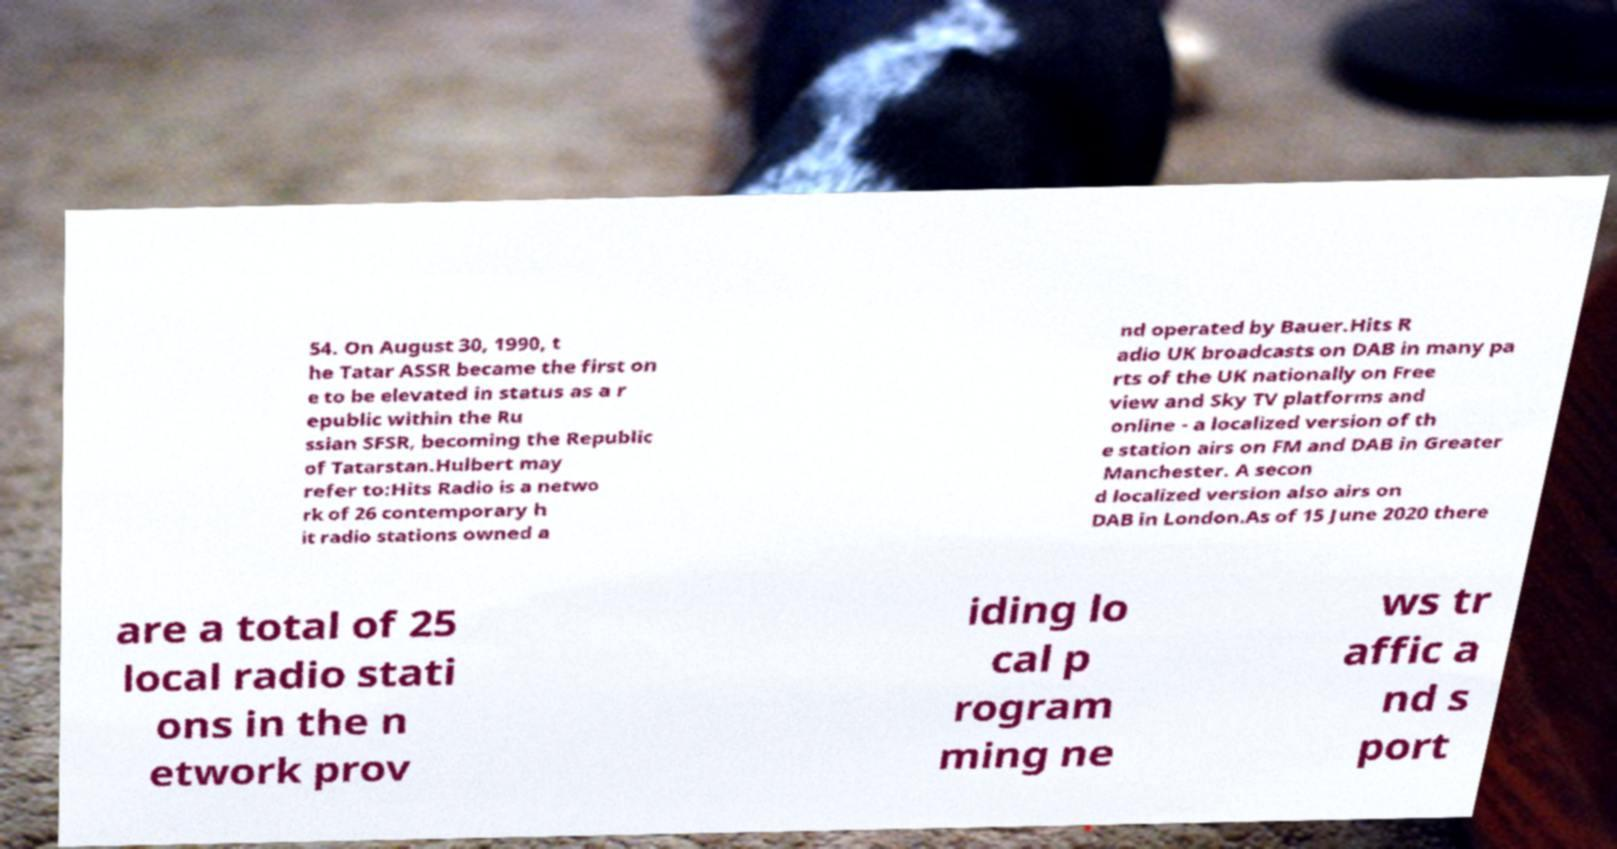There's text embedded in this image that I need extracted. Can you transcribe it verbatim? 54. On August 30, 1990, t he Tatar ASSR became the first on e to be elevated in status as a r epublic within the Ru ssian SFSR, becoming the Republic of Tatarstan.Hulbert may refer to:Hits Radio is a netwo rk of 26 contemporary h it radio stations owned a nd operated by Bauer.Hits R adio UK broadcasts on DAB in many pa rts of the UK nationally on Free view and Sky TV platforms and online - a localized version of th e station airs on FM and DAB in Greater Manchester. A secon d localized version also airs on DAB in London.As of 15 June 2020 there are a total of 25 local radio stati ons in the n etwork prov iding lo cal p rogram ming ne ws tr affic a nd s port 